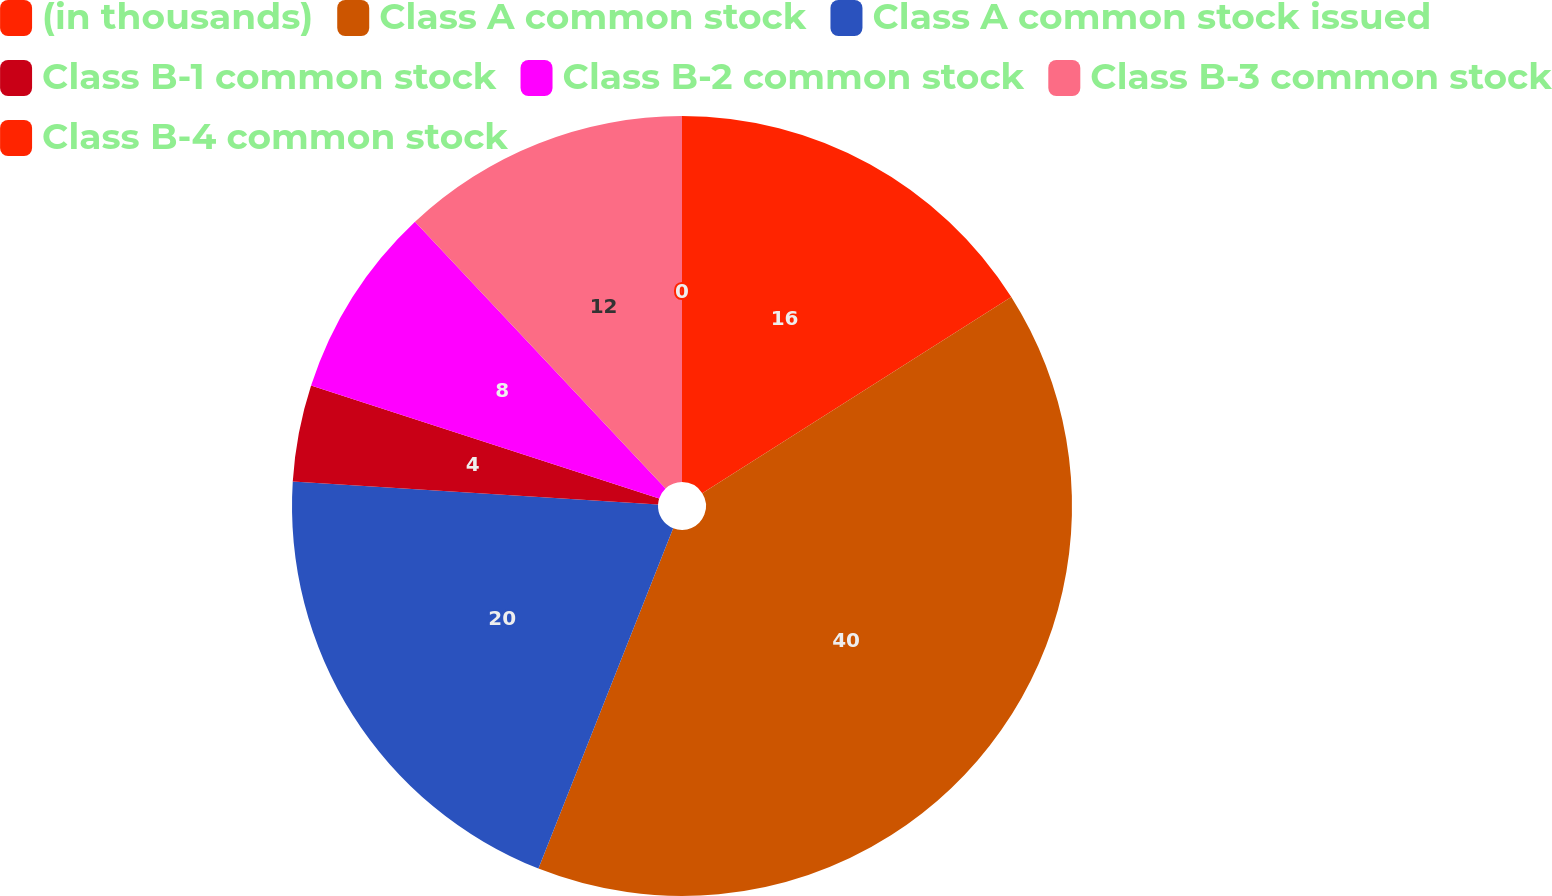Convert chart. <chart><loc_0><loc_0><loc_500><loc_500><pie_chart><fcel>(in thousands)<fcel>Class A common stock<fcel>Class A common stock issued<fcel>Class B-1 common stock<fcel>Class B-2 common stock<fcel>Class B-3 common stock<fcel>Class B-4 common stock<nl><fcel>16.0%<fcel>40.0%<fcel>20.0%<fcel>4.0%<fcel>8.0%<fcel>12.0%<fcel>0.0%<nl></chart> 